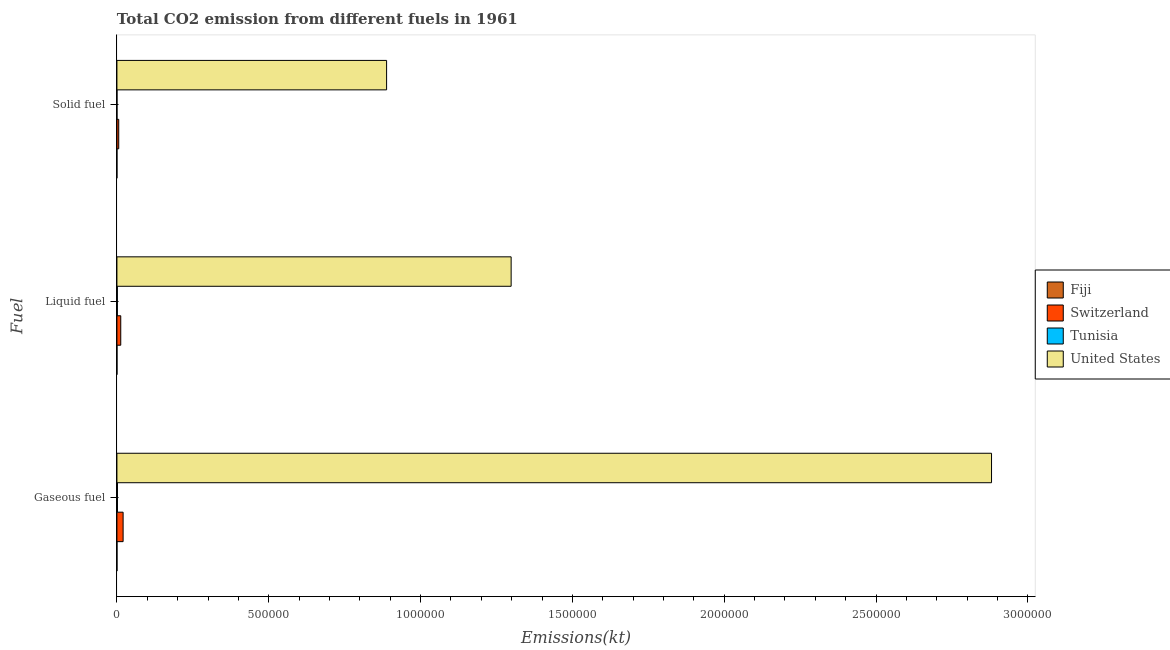How many different coloured bars are there?
Offer a very short reply. 4. How many groups of bars are there?
Provide a short and direct response. 3. Are the number of bars per tick equal to the number of legend labels?
Give a very brief answer. Yes. How many bars are there on the 2nd tick from the top?
Ensure brevity in your answer.  4. What is the label of the 2nd group of bars from the top?
Offer a terse response. Liquid fuel. What is the amount of co2 emissions from solid fuel in Switzerland?
Offer a very short reply. 5984.54. Across all countries, what is the maximum amount of co2 emissions from gaseous fuel?
Your response must be concise. 2.88e+06. Across all countries, what is the minimum amount of co2 emissions from liquid fuel?
Ensure brevity in your answer.  161.35. In which country was the amount of co2 emissions from solid fuel minimum?
Your answer should be compact. Fiji. What is the total amount of co2 emissions from solid fuel in the graph?
Make the answer very short. 8.94e+05. What is the difference between the amount of co2 emissions from solid fuel in Tunisia and that in United States?
Your response must be concise. -8.88e+05. What is the difference between the amount of co2 emissions from gaseous fuel in Fiji and the amount of co2 emissions from solid fuel in Tunisia?
Offer a terse response. 33. What is the average amount of co2 emissions from gaseous fuel per country?
Provide a short and direct response. 7.26e+05. What is the difference between the amount of co2 emissions from liquid fuel and amount of co2 emissions from gaseous fuel in Tunisia?
Your response must be concise. -315.36. What is the ratio of the amount of co2 emissions from gaseous fuel in Switzerland to that in United States?
Make the answer very short. 0.01. Is the amount of co2 emissions from liquid fuel in United States less than that in Tunisia?
Give a very brief answer. No. What is the difference between the highest and the second highest amount of co2 emissions from gaseous fuel?
Keep it short and to the point. 2.86e+06. What is the difference between the highest and the lowest amount of co2 emissions from gaseous fuel?
Provide a succinct answer. 2.88e+06. What does the 1st bar from the top in Liquid fuel represents?
Keep it short and to the point. United States. What does the 1st bar from the bottom in Solid fuel represents?
Provide a succinct answer. Fiji. Are all the bars in the graph horizontal?
Your answer should be compact. Yes. How many countries are there in the graph?
Provide a succinct answer. 4. Are the values on the major ticks of X-axis written in scientific E-notation?
Provide a succinct answer. No. Does the graph contain any zero values?
Your response must be concise. No. Does the graph contain grids?
Make the answer very short. No. Where does the legend appear in the graph?
Keep it short and to the point. Center right. How are the legend labels stacked?
Keep it short and to the point. Vertical. What is the title of the graph?
Your response must be concise. Total CO2 emission from different fuels in 1961. What is the label or title of the X-axis?
Offer a very short reply. Emissions(kt). What is the label or title of the Y-axis?
Your answer should be compact. Fuel. What is the Emissions(kt) in Fiji in Gaseous fuel?
Ensure brevity in your answer.  168.68. What is the Emissions(kt) in Switzerland in Gaseous fuel?
Provide a short and direct response. 2.04e+04. What is the Emissions(kt) in Tunisia in Gaseous fuel?
Give a very brief answer. 1767.49. What is the Emissions(kt) of United States in Gaseous fuel?
Keep it short and to the point. 2.88e+06. What is the Emissions(kt) of Fiji in Liquid fuel?
Your answer should be very brief. 161.35. What is the Emissions(kt) in Switzerland in Liquid fuel?
Your answer should be very brief. 1.26e+04. What is the Emissions(kt) in Tunisia in Liquid fuel?
Your response must be concise. 1452.13. What is the Emissions(kt) of United States in Liquid fuel?
Offer a very short reply. 1.30e+06. What is the Emissions(kt) in Fiji in Solid fuel?
Make the answer very short. 3.67. What is the Emissions(kt) in Switzerland in Solid fuel?
Provide a short and direct response. 5984.54. What is the Emissions(kt) of Tunisia in Solid fuel?
Make the answer very short. 135.68. What is the Emissions(kt) of United States in Solid fuel?
Your response must be concise. 8.88e+05. Across all Fuel, what is the maximum Emissions(kt) in Fiji?
Provide a succinct answer. 168.68. Across all Fuel, what is the maximum Emissions(kt) in Switzerland?
Provide a succinct answer. 2.04e+04. Across all Fuel, what is the maximum Emissions(kt) of Tunisia?
Your answer should be compact. 1767.49. Across all Fuel, what is the maximum Emissions(kt) in United States?
Your answer should be very brief. 2.88e+06. Across all Fuel, what is the minimum Emissions(kt) of Fiji?
Provide a short and direct response. 3.67. Across all Fuel, what is the minimum Emissions(kt) of Switzerland?
Your answer should be very brief. 5984.54. Across all Fuel, what is the minimum Emissions(kt) in Tunisia?
Keep it short and to the point. 135.68. Across all Fuel, what is the minimum Emissions(kt) of United States?
Provide a short and direct response. 8.88e+05. What is the total Emissions(kt) in Fiji in the graph?
Give a very brief answer. 333.7. What is the total Emissions(kt) in Switzerland in the graph?
Offer a very short reply. 3.90e+04. What is the total Emissions(kt) of Tunisia in the graph?
Offer a very short reply. 3355.3. What is the total Emissions(kt) of United States in the graph?
Your response must be concise. 5.07e+06. What is the difference between the Emissions(kt) in Fiji in Gaseous fuel and that in Liquid fuel?
Provide a succinct answer. 7.33. What is the difference between the Emissions(kt) of Switzerland in Gaseous fuel and that in Liquid fuel?
Make the answer very short. 7777.71. What is the difference between the Emissions(kt) of Tunisia in Gaseous fuel and that in Liquid fuel?
Your answer should be very brief. 315.36. What is the difference between the Emissions(kt) of United States in Gaseous fuel and that in Liquid fuel?
Give a very brief answer. 1.58e+06. What is the difference between the Emissions(kt) in Fiji in Gaseous fuel and that in Solid fuel?
Provide a succinct answer. 165.01. What is the difference between the Emissions(kt) of Switzerland in Gaseous fuel and that in Solid fuel?
Make the answer very short. 1.44e+04. What is the difference between the Emissions(kt) of Tunisia in Gaseous fuel and that in Solid fuel?
Provide a succinct answer. 1631.82. What is the difference between the Emissions(kt) in United States in Gaseous fuel and that in Solid fuel?
Make the answer very short. 1.99e+06. What is the difference between the Emissions(kt) in Fiji in Liquid fuel and that in Solid fuel?
Keep it short and to the point. 157.68. What is the difference between the Emissions(kt) of Switzerland in Liquid fuel and that in Solid fuel?
Ensure brevity in your answer.  6626.27. What is the difference between the Emissions(kt) of Tunisia in Liquid fuel and that in Solid fuel?
Ensure brevity in your answer.  1316.45. What is the difference between the Emissions(kt) of United States in Liquid fuel and that in Solid fuel?
Provide a succinct answer. 4.10e+05. What is the difference between the Emissions(kt) of Fiji in Gaseous fuel and the Emissions(kt) of Switzerland in Liquid fuel?
Offer a very short reply. -1.24e+04. What is the difference between the Emissions(kt) of Fiji in Gaseous fuel and the Emissions(kt) of Tunisia in Liquid fuel?
Ensure brevity in your answer.  -1283.45. What is the difference between the Emissions(kt) in Fiji in Gaseous fuel and the Emissions(kt) in United States in Liquid fuel?
Provide a short and direct response. -1.30e+06. What is the difference between the Emissions(kt) of Switzerland in Gaseous fuel and the Emissions(kt) of Tunisia in Liquid fuel?
Your answer should be very brief. 1.89e+04. What is the difference between the Emissions(kt) of Switzerland in Gaseous fuel and the Emissions(kt) of United States in Liquid fuel?
Offer a terse response. -1.28e+06. What is the difference between the Emissions(kt) of Tunisia in Gaseous fuel and the Emissions(kt) of United States in Liquid fuel?
Keep it short and to the point. -1.30e+06. What is the difference between the Emissions(kt) in Fiji in Gaseous fuel and the Emissions(kt) in Switzerland in Solid fuel?
Make the answer very short. -5815.86. What is the difference between the Emissions(kt) of Fiji in Gaseous fuel and the Emissions(kt) of Tunisia in Solid fuel?
Your answer should be very brief. 33. What is the difference between the Emissions(kt) of Fiji in Gaseous fuel and the Emissions(kt) of United States in Solid fuel?
Your answer should be compact. -8.88e+05. What is the difference between the Emissions(kt) in Switzerland in Gaseous fuel and the Emissions(kt) in Tunisia in Solid fuel?
Ensure brevity in your answer.  2.03e+04. What is the difference between the Emissions(kt) of Switzerland in Gaseous fuel and the Emissions(kt) of United States in Solid fuel?
Offer a terse response. -8.68e+05. What is the difference between the Emissions(kt) of Tunisia in Gaseous fuel and the Emissions(kt) of United States in Solid fuel?
Your answer should be very brief. -8.86e+05. What is the difference between the Emissions(kt) in Fiji in Liquid fuel and the Emissions(kt) in Switzerland in Solid fuel?
Your answer should be very brief. -5823.2. What is the difference between the Emissions(kt) in Fiji in Liquid fuel and the Emissions(kt) in Tunisia in Solid fuel?
Offer a terse response. 25.67. What is the difference between the Emissions(kt) in Fiji in Liquid fuel and the Emissions(kt) in United States in Solid fuel?
Provide a short and direct response. -8.88e+05. What is the difference between the Emissions(kt) in Switzerland in Liquid fuel and the Emissions(kt) in Tunisia in Solid fuel?
Keep it short and to the point. 1.25e+04. What is the difference between the Emissions(kt) of Switzerland in Liquid fuel and the Emissions(kt) of United States in Solid fuel?
Provide a succinct answer. -8.76e+05. What is the difference between the Emissions(kt) of Tunisia in Liquid fuel and the Emissions(kt) of United States in Solid fuel?
Your answer should be very brief. -8.87e+05. What is the average Emissions(kt) in Fiji per Fuel?
Ensure brevity in your answer.  111.23. What is the average Emissions(kt) in Switzerland per Fuel?
Ensure brevity in your answer.  1.30e+04. What is the average Emissions(kt) in Tunisia per Fuel?
Provide a short and direct response. 1118.43. What is the average Emissions(kt) of United States per Fuel?
Provide a succinct answer. 1.69e+06. What is the difference between the Emissions(kt) in Fiji and Emissions(kt) in Switzerland in Gaseous fuel?
Give a very brief answer. -2.02e+04. What is the difference between the Emissions(kt) in Fiji and Emissions(kt) in Tunisia in Gaseous fuel?
Offer a very short reply. -1598.81. What is the difference between the Emissions(kt) in Fiji and Emissions(kt) in United States in Gaseous fuel?
Provide a short and direct response. -2.88e+06. What is the difference between the Emissions(kt) of Switzerland and Emissions(kt) of Tunisia in Gaseous fuel?
Offer a very short reply. 1.86e+04. What is the difference between the Emissions(kt) in Switzerland and Emissions(kt) in United States in Gaseous fuel?
Your answer should be compact. -2.86e+06. What is the difference between the Emissions(kt) in Tunisia and Emissions(kt) in United States in Gaseous fuel?
Your answer should be very brief. -2.88e+06. What is the difference between the Emissions(kt) of Fiji and Emissions(kt) of Switzerland in Liquid fuel?
Provide a short and direct response. -1.24e+04. What is the difference between the Emissions(kt) of Fiji and Emissions(kt) of Tunisia in Liquid fuel?
Offer a terse response. -1290.78. What is the difference between the Emissions(kt) in Fiji and Emissions(kt) in United States in Liquid fuel?
Offer a terse response. -1.30e+06. What is the difference between the Emissions(kt) in Switzerland and Emissions(kt) in Tunisia in Liquid fuel?
Provide a short and direct response. 1.12e+04. What is the difference between the Emissions(kt) in Switzerland and Emissions(kt) in United States in Liquid fuel?
Make the answer very short. -1.29e+06. What is the difference between the Emissions(kt) in Tunisia and Emissions(kt) in United States in Liquid fuel?
Your response must be concise. -1.30e+06. What is the difference between the Emissions(kt) in Fiji and Emissions(kt) in Switzerland in Solid fuel?
Your answer should be compact. -5980.88. What is the difference between the Emissions(kt) in Fiji and Emissions(kt) in Tunisia in Solid fuel?
Make the answer very short. -132.01. What is the difference between the Emissions(kt) of Fiji and Emissions(kt) of United States in Solid fuel?
Provide a succinct answer. -8.88e+05. What is the difference between the Emissions(kt) in Switzerland and Emissions(kt) in Tunisia in Solid fuel?
Make the answer very short. 5848.86. What is the difference between the Emissions(kt) in Switzerland and Emissions(kt) in United States in Solid fuel?
Make the answer very short. -8.82e+05. What is the difference between the Emissions(kt) in Tunisia and Emissions(kt) in United States in Solid fuel?
Provide a succinct answer. -8.88e+05. What is the ratio of the Emissions(kt) in Fiji in Gaseous fuel to that in Liquid fuel?
Provide a short and direct response. 1.05. What is the ratio of the Emissions(kt) of Switzerland in Gaseous fuel to that in Liquid fuel?
Make the answer very short. 1.62. What is the ratio of the Emissions(kt) of Tunisia in Gaseous fuel to that in Liquid fuel?
Keep it short and to the point. 1.22. What is the ratio of the Emissions(kt) of United States in Gaseous fuel to that in Liquid fuel?
Make the answer very short. 2.22. What is the ratio of the Emissions(kt) of Switzerland in Gaseous fuel to that in Solid fuel?
Offer a very short reply. 3.41. What is the ratio of the Emissions(kt) in Tunisia in Gaseous fuel to that in Solid fuel?
Provide a succinct answer. 13.03. What is the ratio of the Emissions(kt) of United States in Gaseous fuel to that in Solid fuel?
Make the answer very short. 3.24. What is the ratio of the Emissions(kt) of Fiji in Liquid fuel to that in Solid fuel?
Provide a succinct answer. 44. What is the ratio of the Emissions(kt) of Switzerland in Liquid fuel to that in Solid fuel?
Provide a short and direct response. 2.11. What is the ratio of the Emissions(kt) of Tunisia in Liquid fuel to that in Solid fuel?
Your response must be concise. 10.7. What is the ratio of the Emissions(kt) of United States in Liquid fuel to that in Solid fuel?
Ensure brevity in your answer.  1.46. What is the difference between the highest and the second highest Emissions(kt) of Fiji?
Ensure brevity in your answer.  7.33. What is the difference between the highest and the second highest Emissions(kt) of Switzerland?
Ensure brevity in your answer.  7777.71. What is the difference between the highest and the second highest Emissions(kt) of Tunisia?
Keep it short and to the point. 315.36. What is the difference between the highest and the second highest Emissions(kt) of United States?
Provide a short and direct response. 1.58e+06. What is the difference between the highest and the lowest Emissions(kt) in Fiji?
Keep it short and to the point. 165.01. What is the difference between the highest and the lowest Emissions(kt) in Switzerland?
Your answer should be compact. 1.44e+04. What is the difference between the highest and the lowest Emissions(kt) in Tunisia?
Keep it short and to the point. 1631.82. What is the difference between the highest and the lowest Emissions(kt) in United States?
Provide a short and direct response. 1.99e+06. 